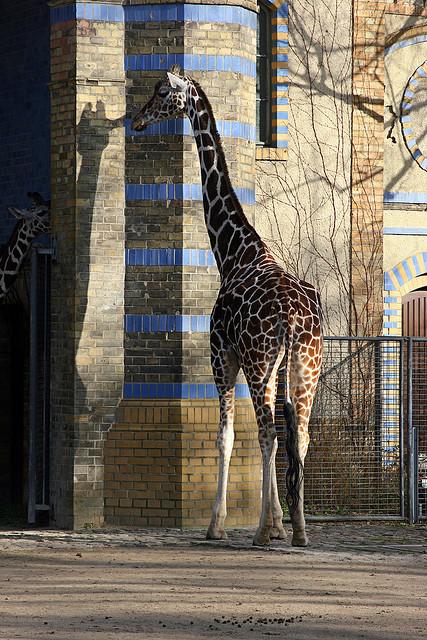Is this image in a natural setting?
Quick response, please. No. How many animals are in the picture?
Give a very brief answer. 1. What animal is in the picture?
Keep it brief. Giraffe. 